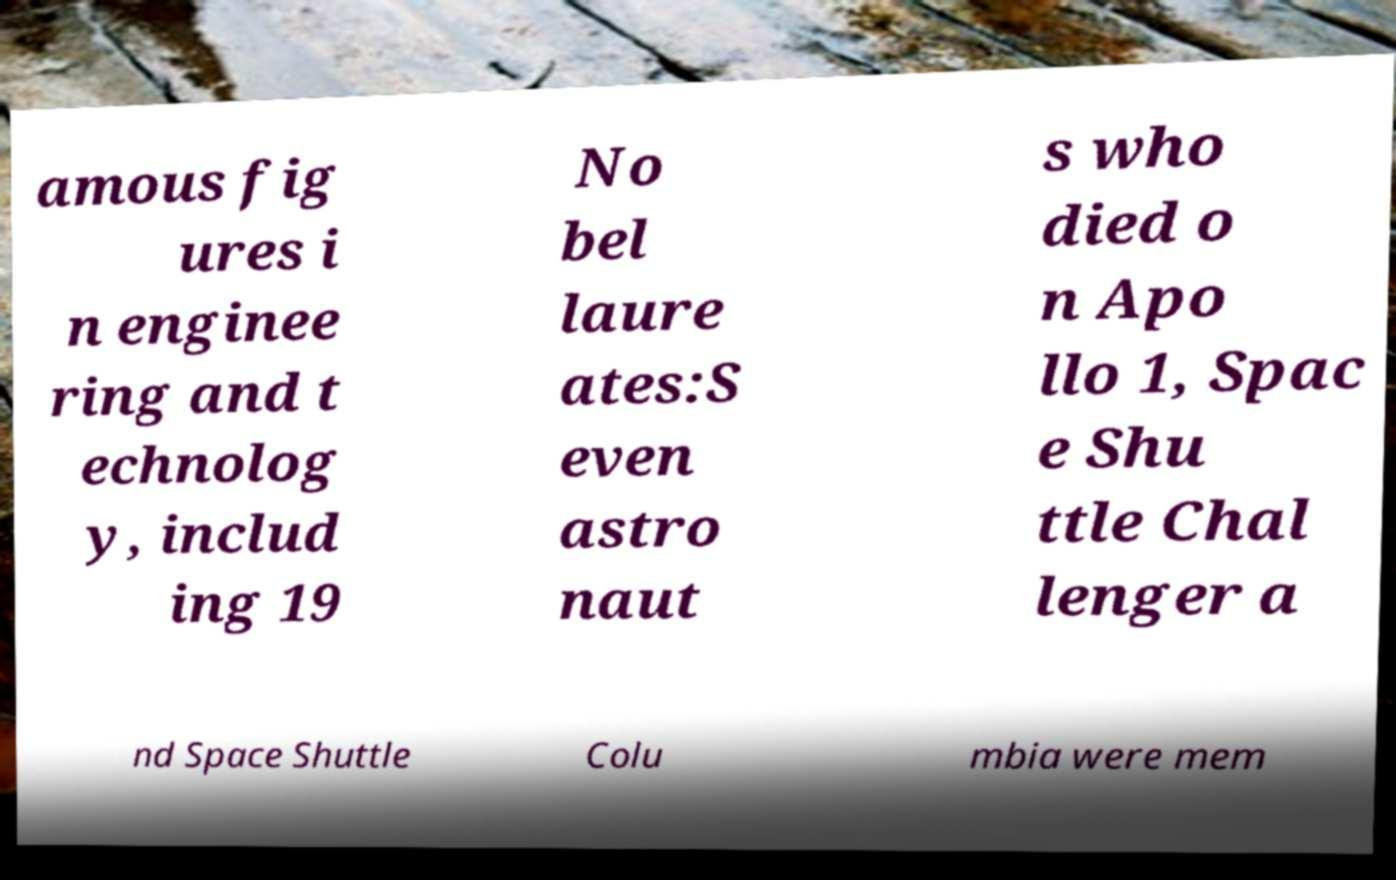There's text embedded in this image that I need extracted. Can you transcribe it verbatim? amous fig ures i n enginee ring and t echnolog y, includ ing 19 No bel laure ates:S even astro naut s who died o n Apo llo 1, Spac e Shu ttle Chal lenger a nd Space Shuttle Colu mbia were mem 